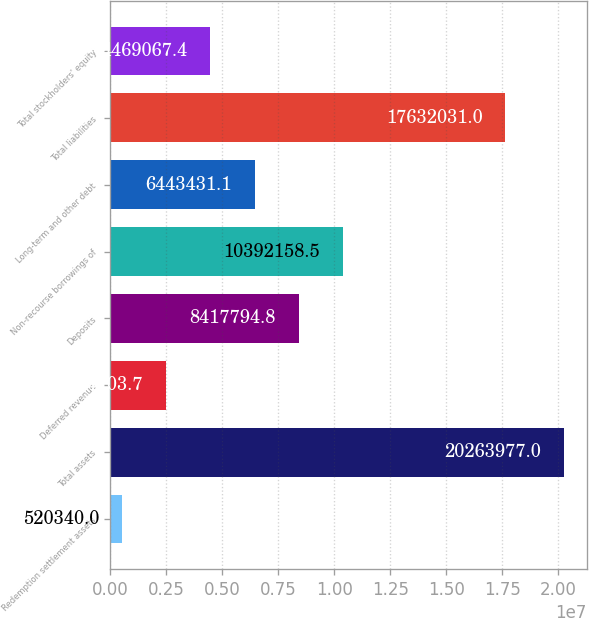Convert chart. <chart><loc_0><loc_0><loc_500><loc_500><bar_chart><fcel>Redemption settlement assets<fcel>Total assets<fcel>Deferred revenue<fcel>Deposits<fcel>Non-recourse borrowings of<fcel>Long-term and other debt<fcel>Total liabilities<fcel>Total stockholders' equity<nl><fcel>520340<fcel>2.0264e+07<fcel>2.4947e+06<fcel>8.41779e+06<fcel>1.03922e+07<fcel>6.44343e+06<fcel>1.7632e+07<fcel>4.46907e+06<nl></chart> 